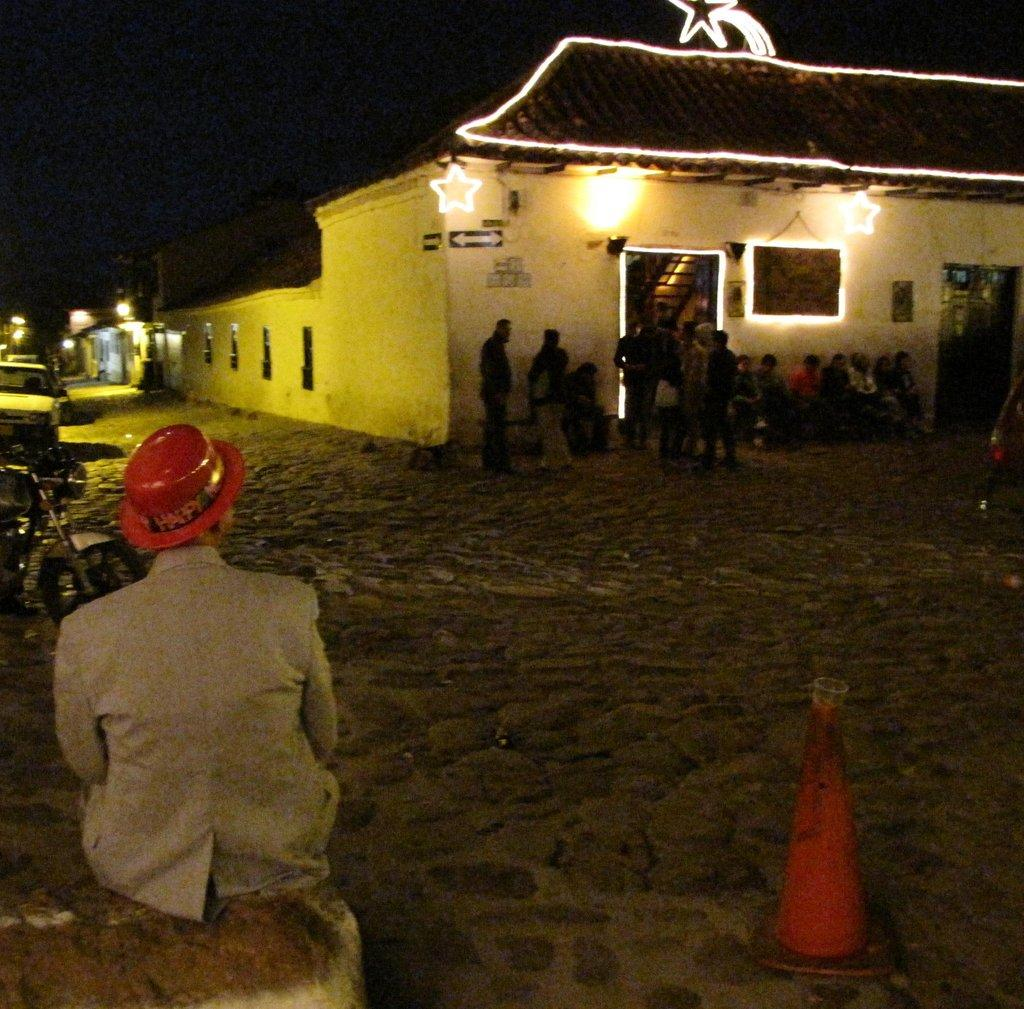Where is the person sitting in the image? The person is sitting in the left corner of the image. What is in front of the person sitting in the left corner? There are other persons and a building in front of the person sitting in the left corner. What else can be seen in the left corner of the image? There are vehicles in the left corner of the image. What type of plough is being used by the person sitting in the image? There is no plough present in the image; it features a person sitting in the left corner with other persons and a building in front of them. What emotion is the person sitting in the image feeling due to the presence of the other persons? The image does not provide information about the emotions of the person sitting in the image, so we cannot determine if they feel shame or any other emotion. 